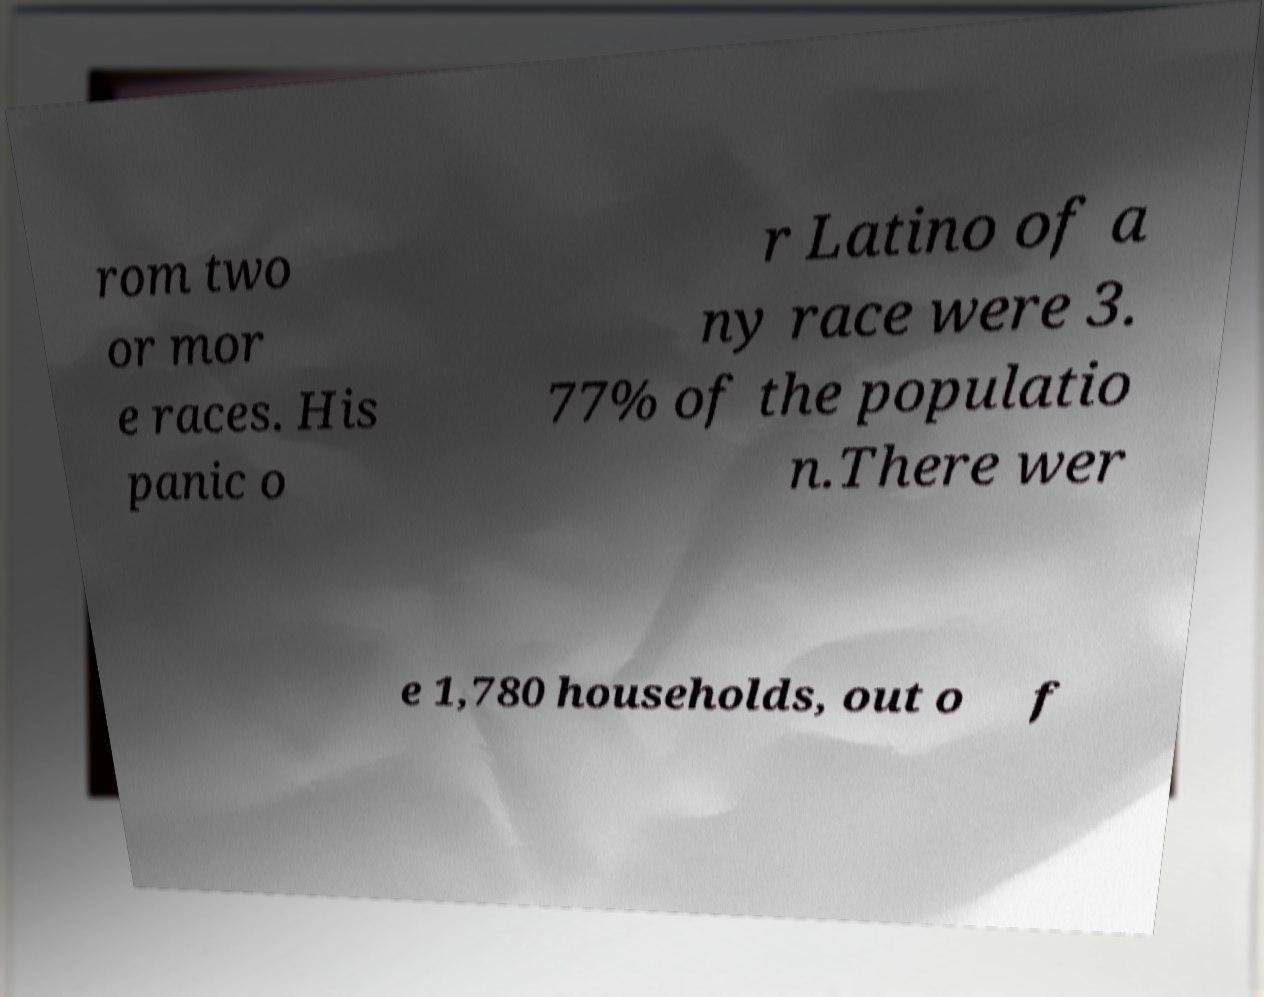What messages or text are displayed in this image? I need them in a readable, typed format. rom two or mor e races. His panic o r Latino of a ny race were 3. 77% of the populatio n.There wer e 1,780 households, out o f 